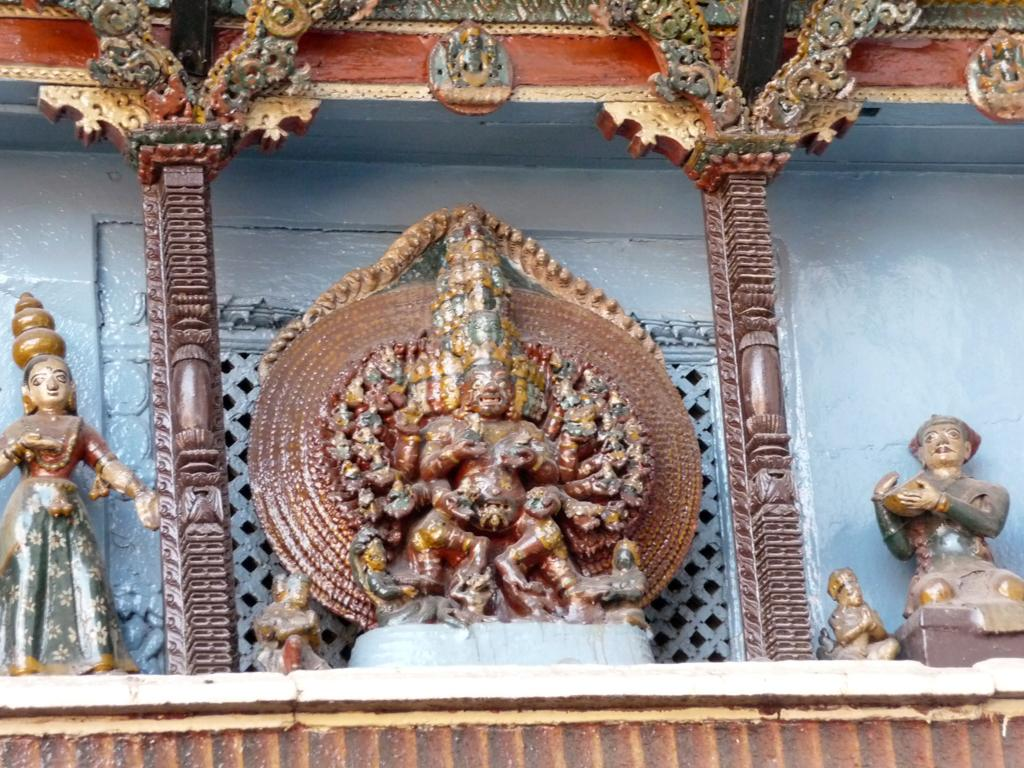What type of objects can be seen in the image? There are sculptures in the image. Where are the sculptures located? The sculptures are on a table. What type of lace can be seen on the sculptures in the image? There is no lace present on the sculptures in the image. Are there any pickles visible on the table with the sculptures? There are no pickles present in the image. 